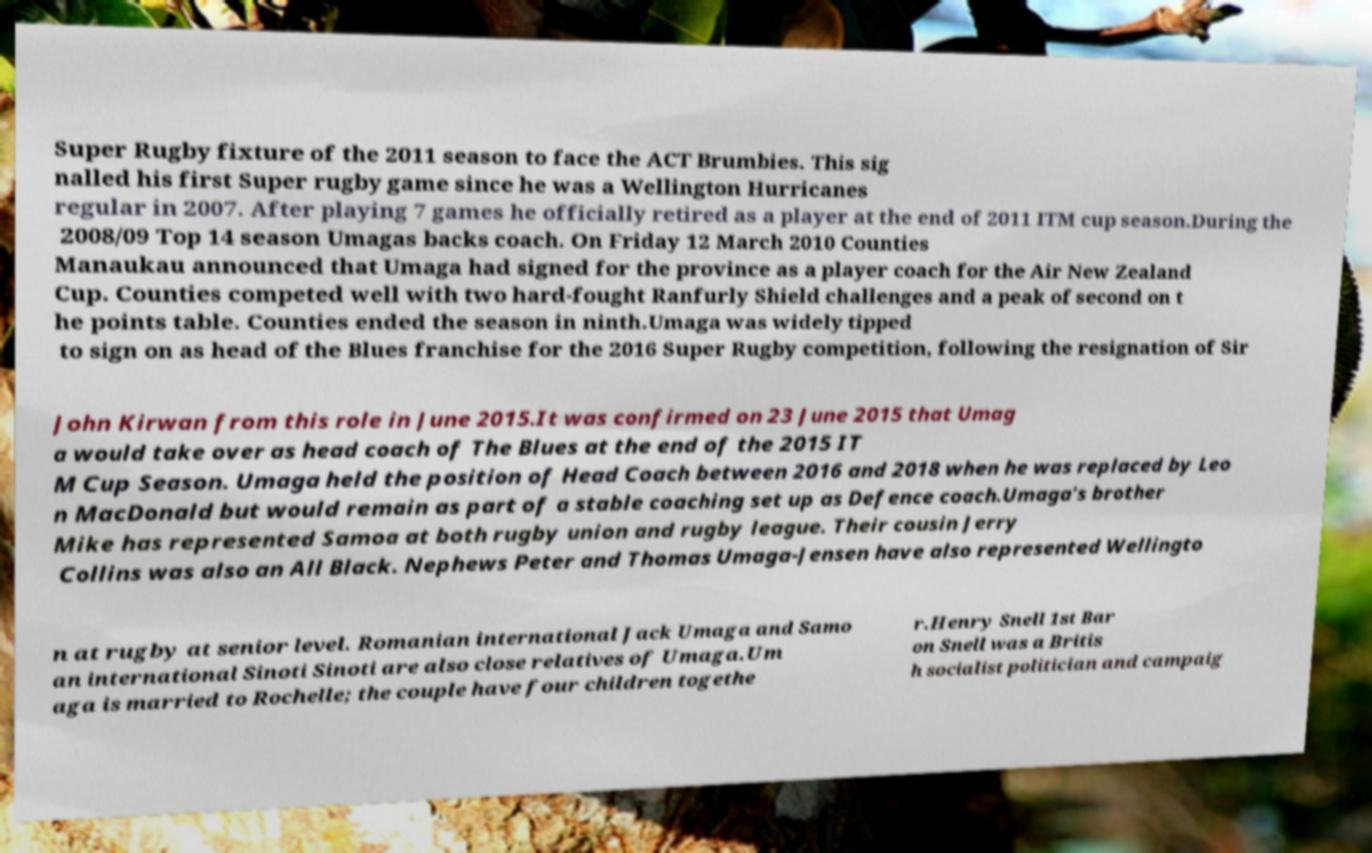Can you read and provide the text displayed in the image?This photo seems to have some interesting text. Can you extract and type it out for me? Super Rugby fixture of the 2011 season to face the ACT Brumbies. This sig nalled his first Super rugby game since he was a Wellington Hurricanes regular in 2007. After playing 7 games he officially retired as a player at the end of 2011 ITM cup season.During the 2008/09 Top 14 season Umagas backs coach. On Friday 12 March 2010 Counties Manaukau announced that Umaga had signed for the province as a player coach for the Air New Zealand Cup. Counties competed well with two hard-fought Ranfurly Shield challenges and a peak of second on t he points table. Counties ended the season in ninth.Umaga was widely tipped to sign on as head of the Blues franchise for the 2016 Super Rugby competition, following the resignation of Sir John Kirwan from this role in June 2015.It was confirmed on 23 June 2015 that Umag a would take over as head coach of The Blues at the end of the 2015 IT M Cup Season. Umaga held the position of Head Coach between 2016 and 2018 when he was replaced by Leo n MacDonald but would remain as part of a stable coaching set up as Defence coach.Umaga's brother Mike has represented Samoa at both rugby union and rugby league. Their cousin Jerry Collins was also an All Black. Nephews Peter and Thomas Umaga-Jensen have also represented Wellingto n at rugby at senior level. Romanian international Jack Umaga and Samo an international Sinoti Sinoti are also close relatives of Umaga.Um aga is married to Rochelle; the couple have four children togethe r.Henry Snell 1st Bar on Snell was a Britis h socialist politician and campaig 